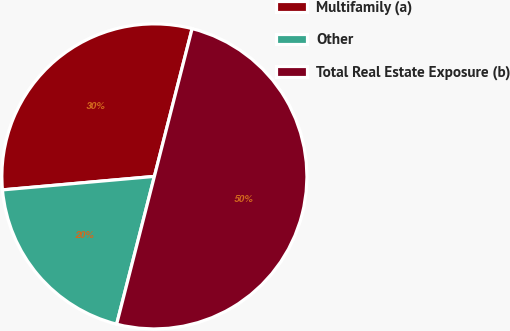Convert chart. <chart><loc_0><loc_0><loc_500><loc_500><pie_chart><fcel>Multifamily (a)<fcel>Other<fcel>Total Real Estate Exposure (b)<nl><fcel>30.39%<fcel>19.61%<fcel>50.0%<nl></chart> 